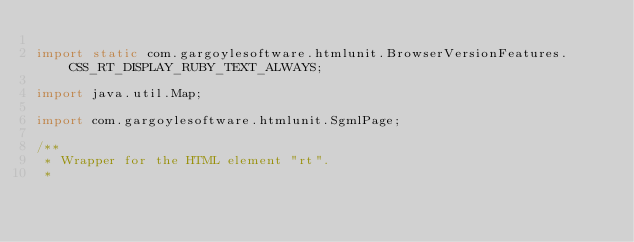Convert code to text. <code><loc_0><loc_0><loc_500><loc_500><_Java_>
import static com.gargoylesoftware.htmlunit.BrowserVersionFeatures.CSS_RT_DISPLAY_RUBY_TEXT_ALWAYS;

import java.util.Map;

import com.gargoylesoftware.htmlunit.SgmlPage;

/**
 * Wrapper for the HTML element "rt".
 *</code> 